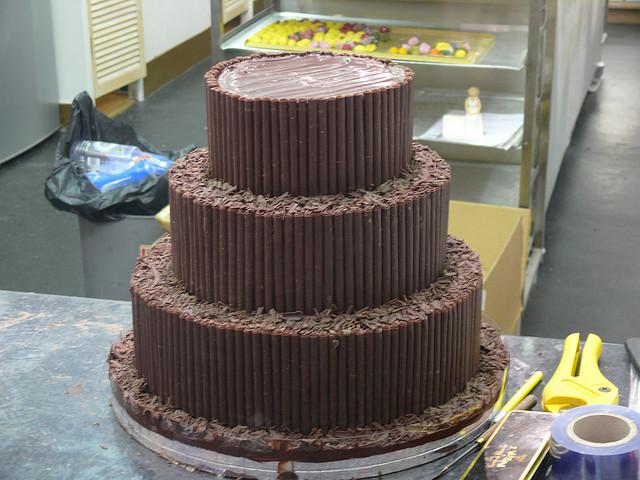What color is the cake?
Write a very short answer. Brown. How many tiers does this cake have?
Quick response, please. 3. Is this food sweet?
Quick response, please. Yes. 